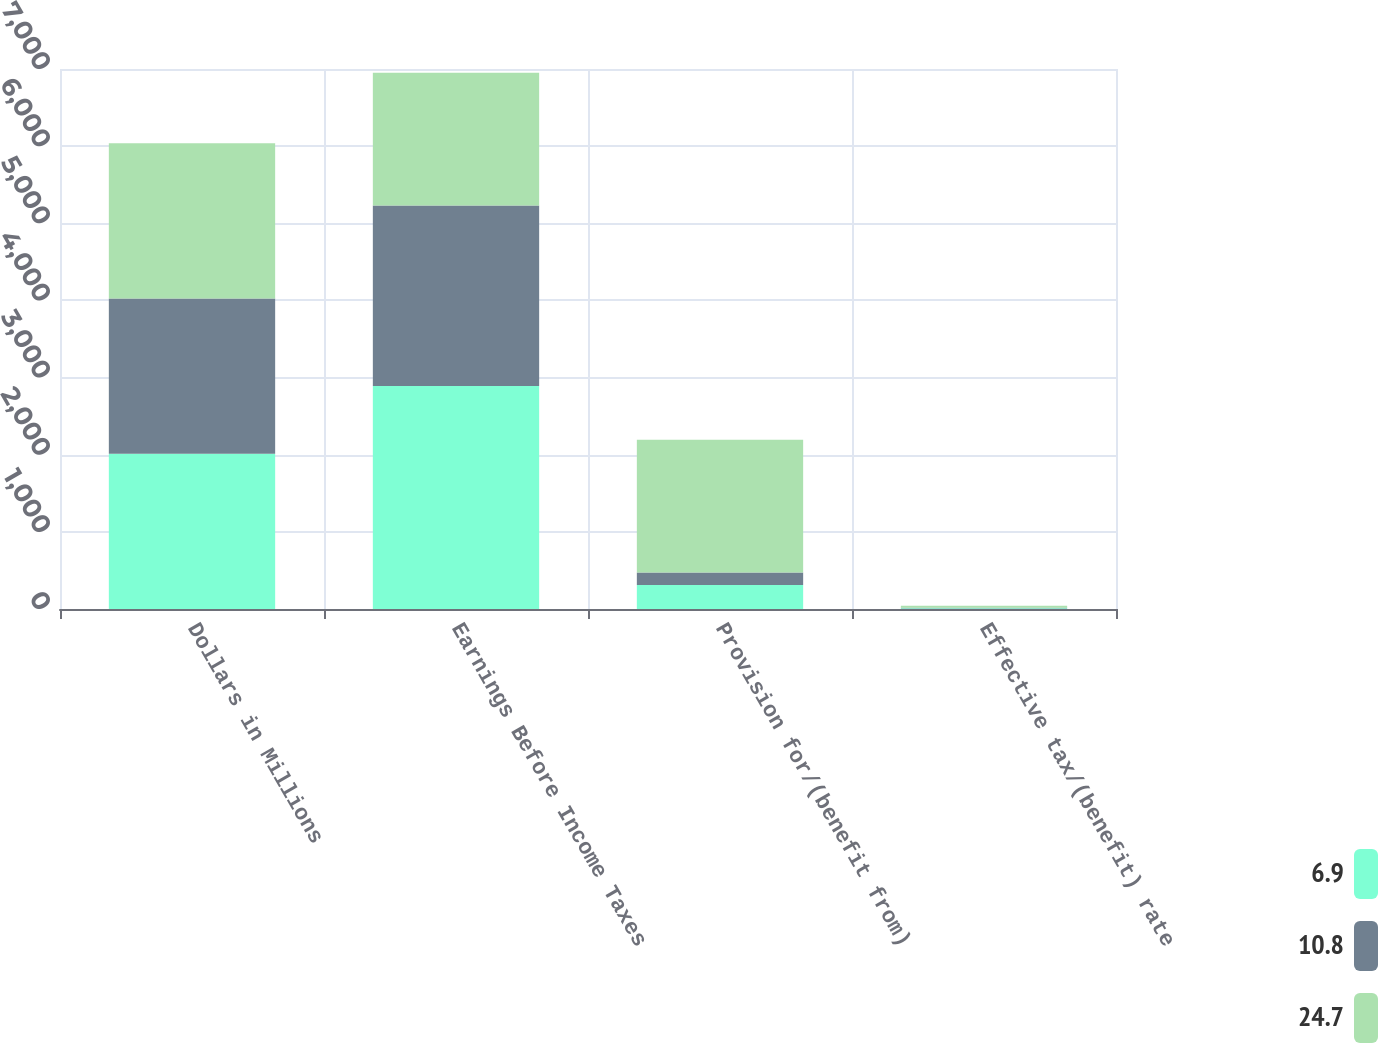Convert chart. <chart><loc_0><loc_0><loc_500><loc_500><stacked_bar_chart><ecel><fcel>Dollars in Millions<fcel>Earnings Before Income Taxes<fcel>Provision for/(benefit from)<fcel>Effective tax/(benefit) rate<nl><fcel>6.9<fcel>2013<fcel>2891<fcel>311<fcel>10.8<nl><fcel>10.8<fcel>2012<fcel>2340<fcel>161<fcel>6.9<nl><fcel>24.7<fcel>2011<fcel>1721<fcel>1721<fcel>24.7<nl></chart> 